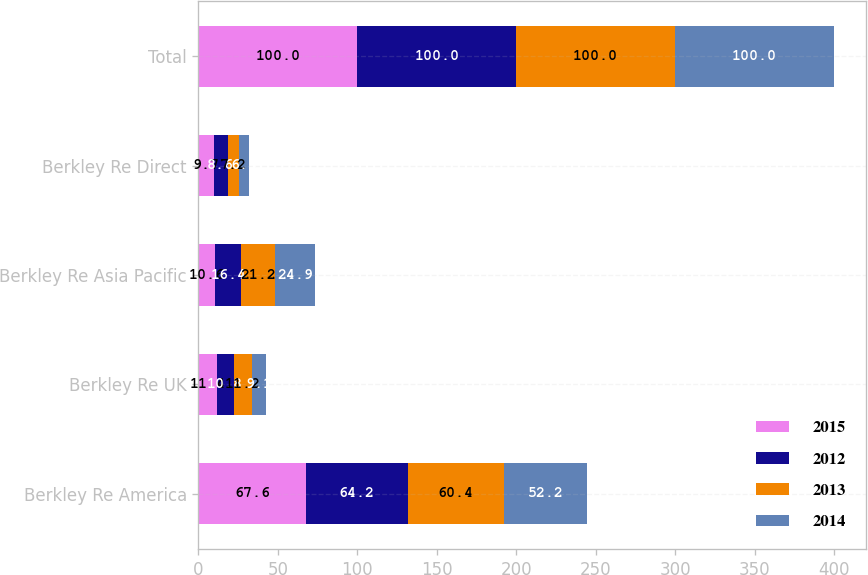Convert chart to OTSL. <chart><loc_0><loc_0><loc_500><loc_500><stacked_bar_chart><ecel><fcel>Berkley Re America<fcel>Berkley Re UK<fcel>Berkley Re Asia Pacific<fcel>Berkley Re Direct<fcel>Total<nl><fcel>2015<fcel>67.6<fcel>11.4<fcel>10.6<fcel>9.7<fcel>100<nl><fcel>2012<fcel>64.2<fcel>10.8<fcel>16.4<fcel>8.6<fcel>100<nl><fcel>2013<fcel>60.4<fcel>11.2<fcel>21.2<fcel>7.2<fcel>100<nl><fcel>2014<fcel>52.2<fcel>9.1<fcel>24.9<fcel>6.5<fcel>100<nl></chart> 